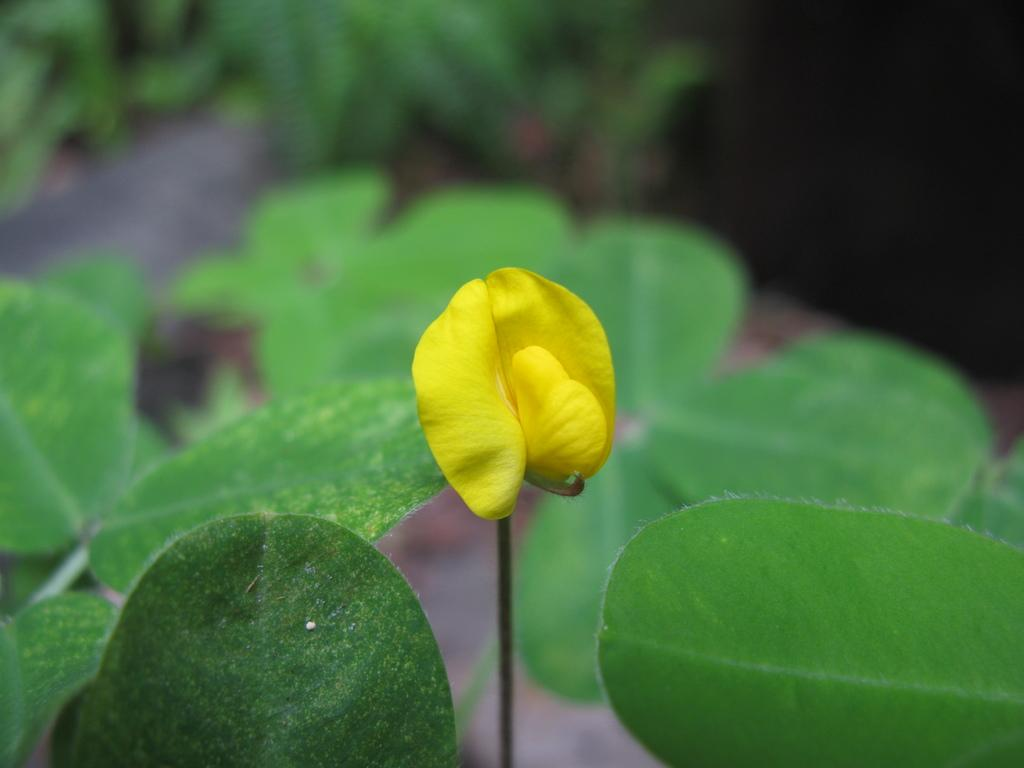What type of flower is in the image? There is a yellow flower in the image. What else can be seen in the image besides the flower? There are leaves visible in the image. What is visible in the background of the image? There are plants in the background of the image. What type of songs can be heard coming from the flower in the image? There are no songs coming from the flower in the image, as flowers do not produce or emit sounds. 